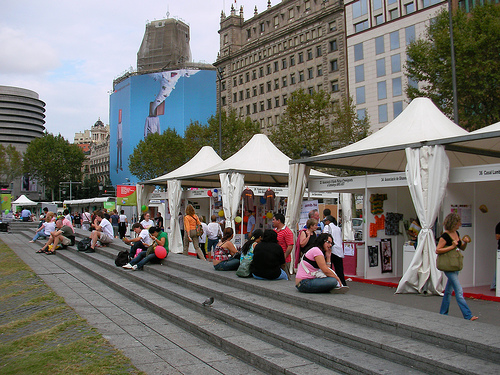<image>
Can you confirm if the person is on the step? Yes. Looking at the image, I can see the person is positioned on top of the step, with the step providing support. 